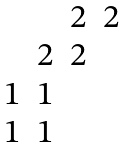Convert formula to latex. <formula><loc_0><loc_0><loc_500><loc_500>\begin{matrix} & & 2 & 2 \\ & 2 & 2 & \\ 1 & 1 & & \\ 1 & 1 & & \end{matrix}</formula> 